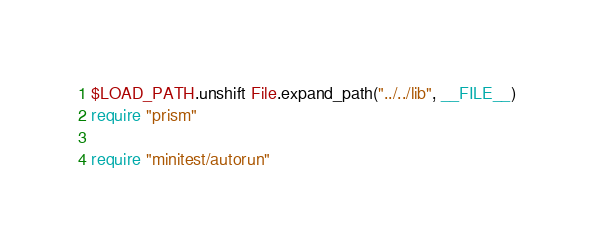Convert code to text. <code><loc_0><loc_0><loc_500><loc_500><_Ruby_>$LOAD_PATH.unshift File.expand_path("../../lib", __FILE__)
require "prism"

require "minitest/autorun"
</code> 